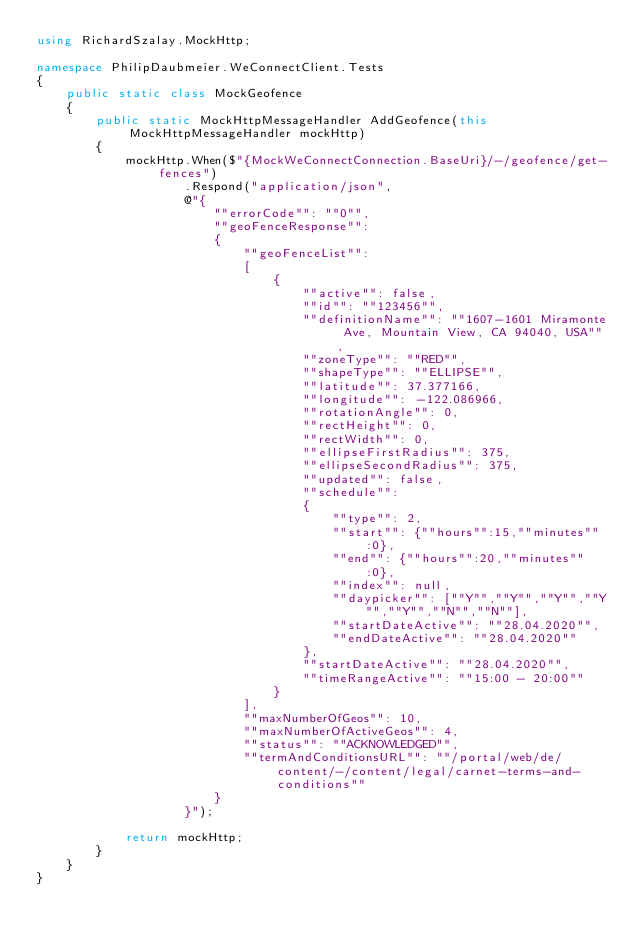Convert code to text. <code><loc_0><loc_0><loc_500><loc_500><_C#_>using RichardSzalay.MockHttp;

namespace PhilipDaubmeier.WeConnectClient.Tests
{
    public static class MockGeofence
    {
        public static MockHttpMessageHandler AddGeofence(this MockHttpMessageHandler mockHttp)
        {
            mockHttp.When($"{MockWeConnectConnection.BaseUri}/-/geofence/get-fences")
                    .Respond("application/json",
                    @"{
                        ""errorCode"": ""0"",
                        ""geoFenceResponse"":
                        {
                            ""geoFenceList"":
                            [
                                {
                                    ""active"": false,
                                    ""id"": ""123456"",
                                    ""definitionName"": ""1607-1601 Miramonte Ave, Mountain View, CA 94040, USA"",
                                    ""zoneType"": ""RED"",
                                    ""shapeType"": ""ELLIPSE"",
                                    ""latitude"": 37.377166,
                                    ""longitude"": -122.086966,
                                    ""rotationAngle"": 0,
                                    ""rectHeight"": 0,
                                    ""rectWidth"": 0,
                                    ""ellipseFirstRadius"": 375,
                                    ""ellipseSecondRadius"": 375,
                                    ""updated"": false,
                                    ""schedule"":
                                    {
                                        ""type"": 2,
                                        ""start"": {""hours"":15,""minutes"":0},
                                        ""end"": {""hours"":20,""minutes"":0},
                                        ""index"": null,
                                        ""daypicker"": [""Y"",""Y"",""Y"",""Y"",""Y"",""N"",""N""],
                                        ""startDateActive"": ""28.04.2020"",
                                        ""endDateActive"": ""28.04.2020""
                                    },
                                    ""startDateActive"": ""28.04.2020"",
                                    ""timeRangeActive"": ""15:00 - 20:00""
                                }
                            ],
                            ""maxNumberOfGeos"": 10,
                            ""maxNumberOfActiveGeos"": 4,
                            ""status"": ""ACKNOWLEDGED"",
                            ""termAndConditionsURL"": ""/portal/web/de/content/-/content/legal/carnet-terms-and-conditions""
                        }
                    }");

            return mockHttp;
        }
    }
}</code> 